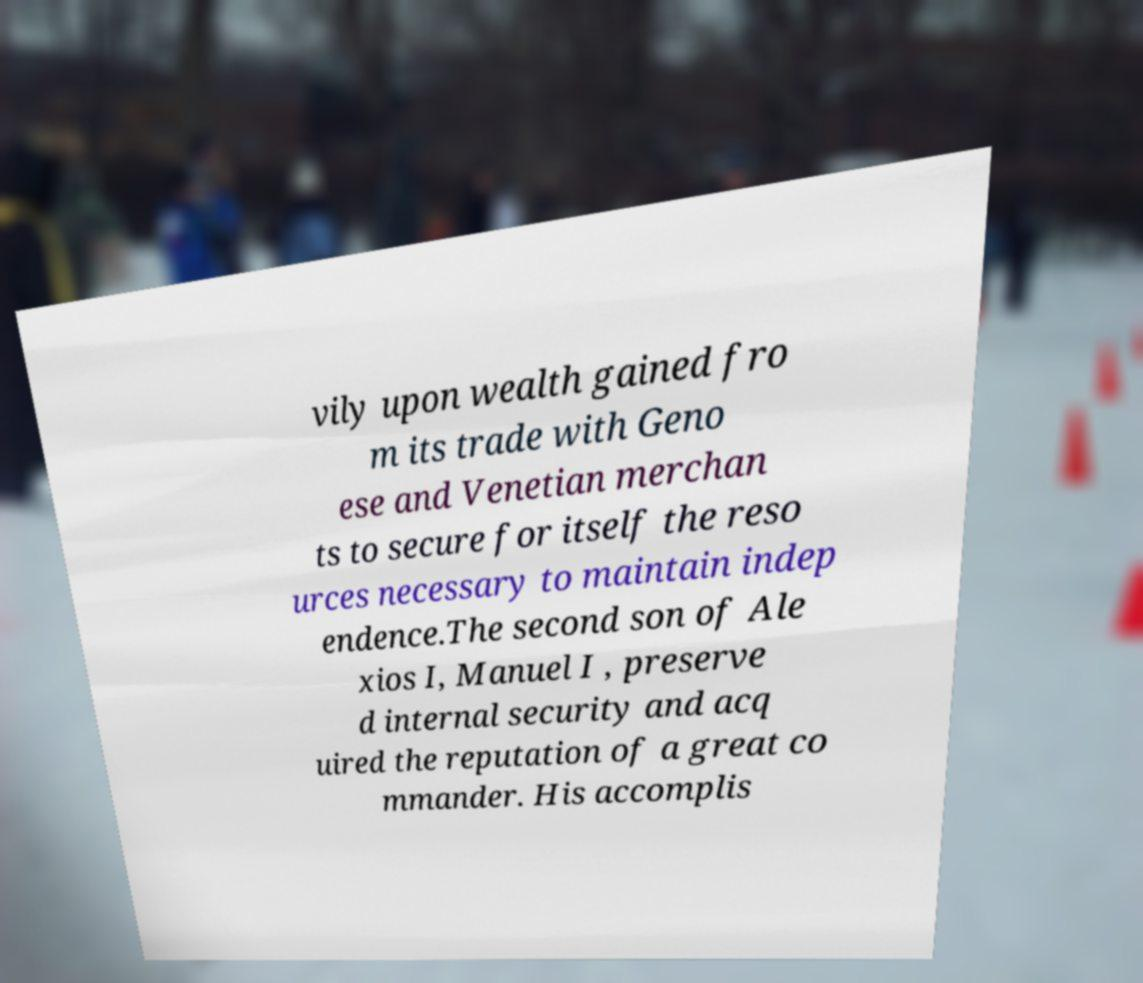Could you assist in decoding the text presented in this image and type it out clearly? vily upon wealth gained fro m its trade with Geno ese and Venetian merchan ts to secure for itself the reso urces necessary to maintain indep endence.The second son of Ale xios I, Manuel I , preserve d internal security and acq uired the reputation of a great co mmander. His accomplis 